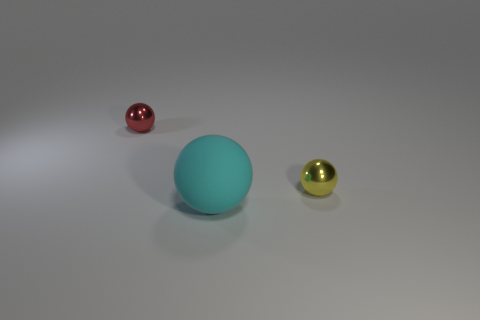Is there a tiny yellow sphere to the right of the shiny thing on the right side of the red object?
Make the answer very short. No. Is the big cyan thing made of the same material as the small yellow sphere?
Ensure brevity in your answer.  No. Are there any red things behind the matte sphere?
Your answer should be compact. Yes. The cyan ball in front of the metallic object that is to the left of the big object is made of what material?
Offer a terse response. Rubber. There is a red object that is the same shape as the small yellow object; what is its size?
Offer a terse response. Small. What is the color of the ball that is to the left of the tiny yellow metal object and behind the big cyan thing?
Offer a terse response. Red. Do the yellow metal object that is in front of the red object and the cyan thing have the same size?
Give a very brief answer. No. Are there any other things that are the same shape as the cyan rubber object?
Keep it short and to the point. Yes. Is the material of the red sphere the same as the tiny thing that is on the right side of the big cyan thing?
Ensure brevity in your answer.  Yes. What number of cyan objects are small spheres or big balls?
Make the answer very short. 1. 